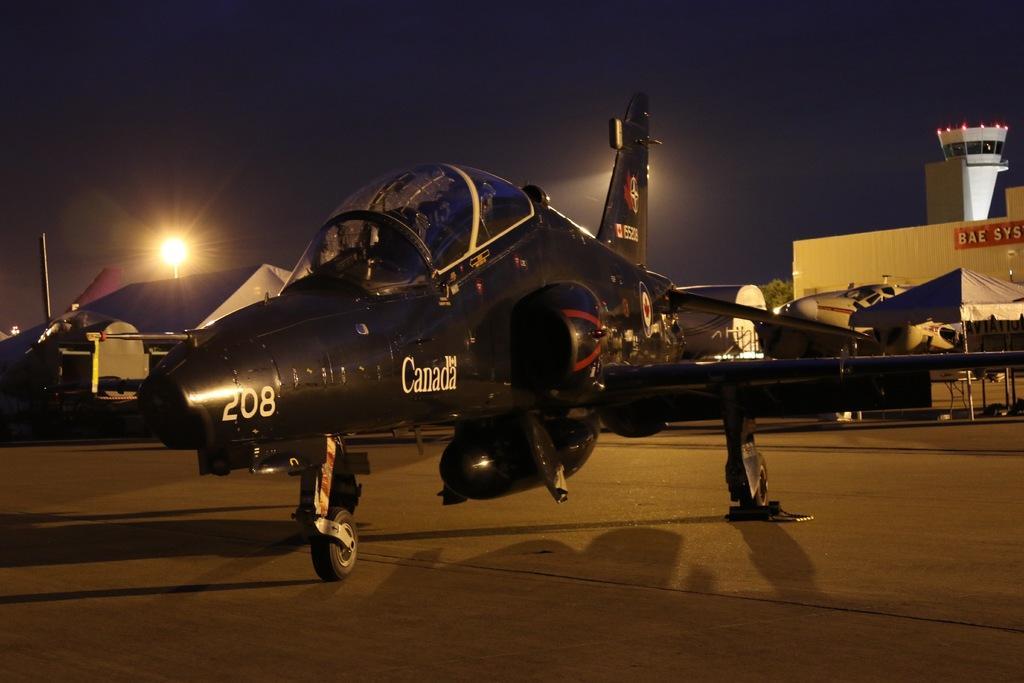In one or two sentences, can you explain what this image depicts? In the middle of the image there is a black color aircraft on the run way. In the background there are stores with name boards, tents, poles with street lights. And to the top of the image there is a sky. 